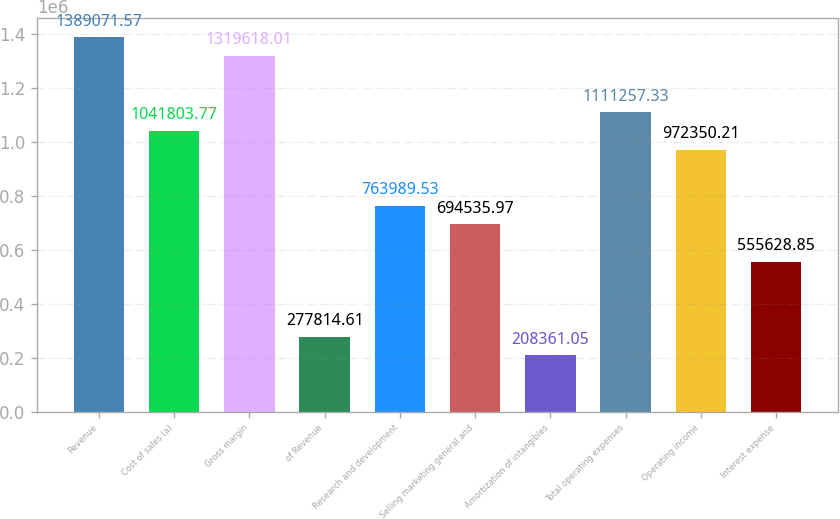<chart> <loc_0><loc_0><loc_500><loc_500><bar_chart><fcel>Revenue<fcel>Cost of sales (a)<fcel>Gross margin<fcel>of Revenue<fcel>Research and development<fcel>Selling marketing general and<fcel>Amortization of intangibles<fcel>Total operating expenses<fcel>Operating income<fcel>Interest expense<nl><fcel>1.38907e+06<fcel>1.0418e+06<fcel>1.31962e+06<fcel>277815<fcel>763990<fcel>694536<fcel>208361<fcel>1.11126e+06<fcel>972350<fcel>555629<nl></chart> 